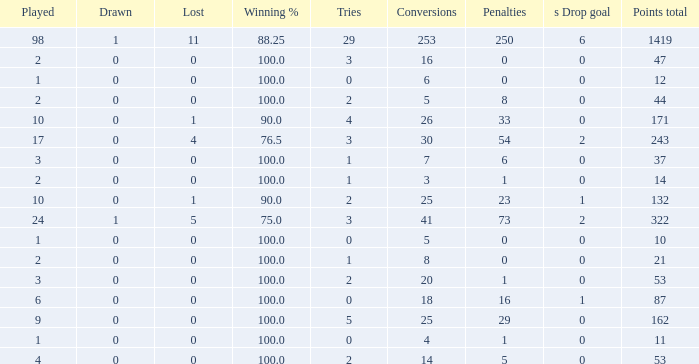How many ties did he have when he had 1 penalties and more than 20 conversions? None. 